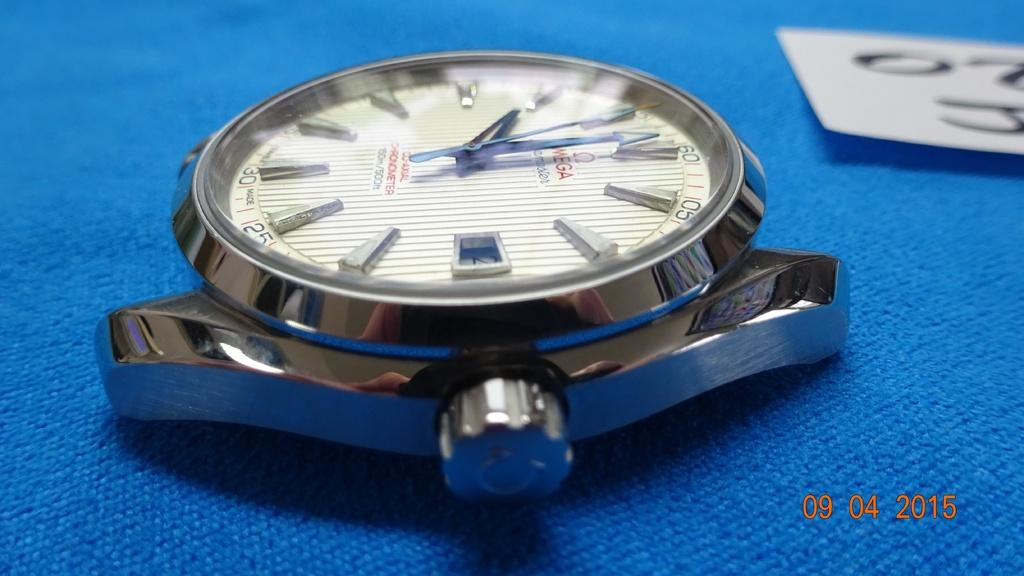<image>
Relay a brief, clear account of the picture shown. An Omega watch with no band sits on a blue table. 